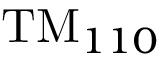<formula> <loc_0><loc_0><loc_500><loc_500>T M _ { 1 1 0 }</formula> 